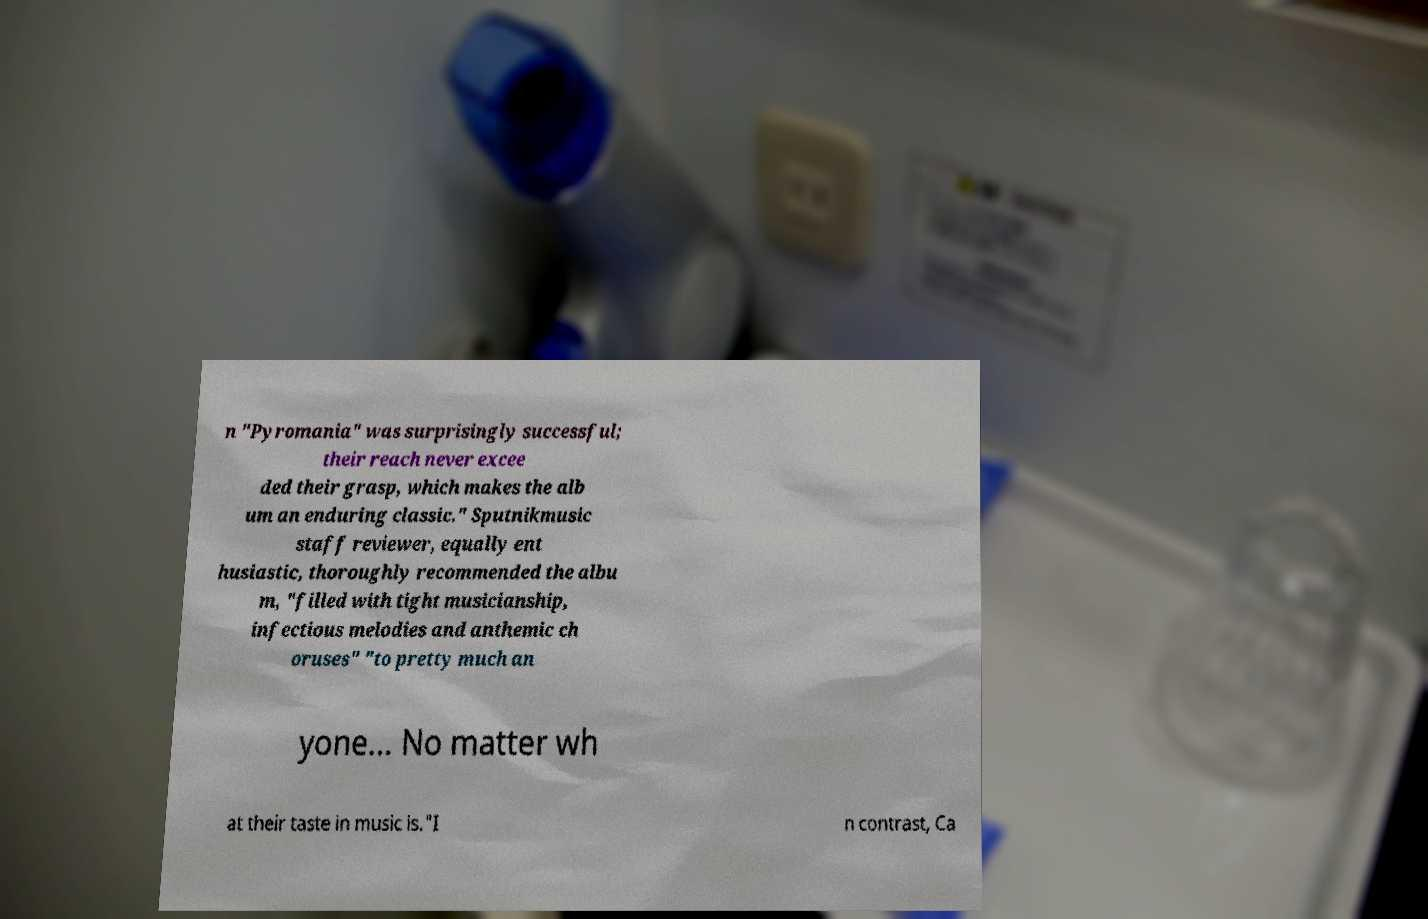What messages or text are displayed in this image? I need them in a readable, typed format. n "Pyromania" was surprisingly successful; their reach never excee ded their grasp, which makes the alb um an enduring classic." Sputnikmusic staff reviewer, equally ent husiastic, thoroughly recommended the albu m, "filled with tight musicianship, infectious melodies and anthemic ch oruses" "to pretty much an yone… No matter wh at their taste in music is."I n contrast, Ca 